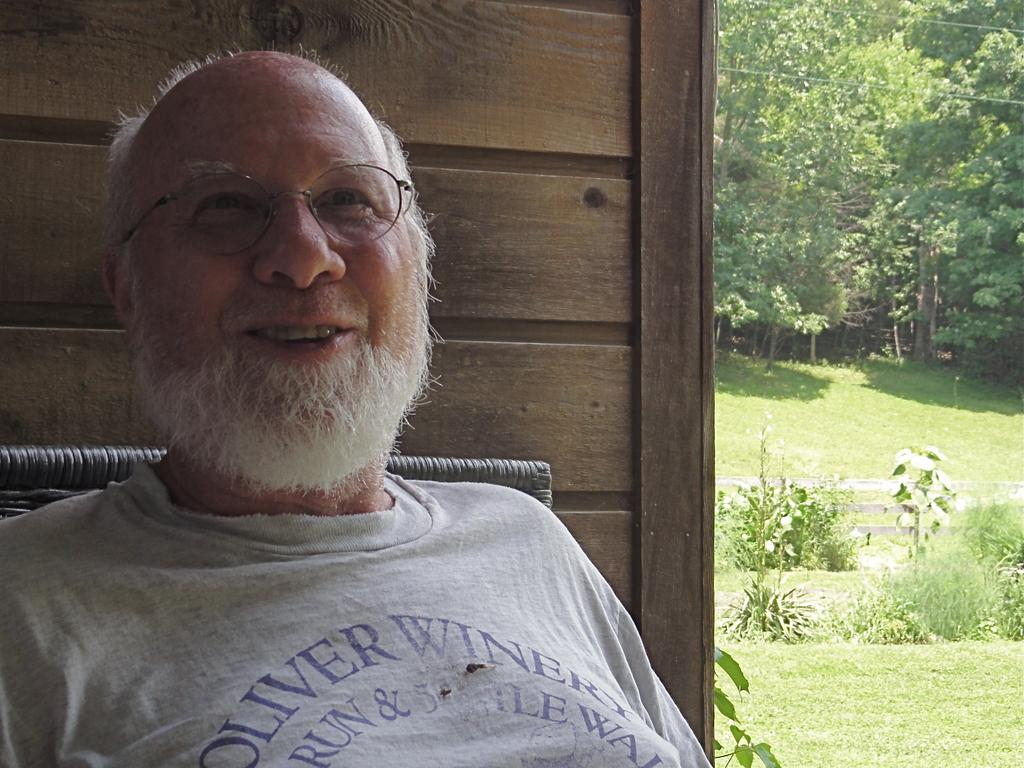What is the main subject of the image? There is a man in the image. Can you describe the man's appearance? The man is wearing spectacles and smiling. What is located behind the man in the image? There is an object behind the man, but its specific details are not mentioned in the facts. What can be seen on the sides or in the background of the image? There is a wall, grass, plants, a fence, and trees visible in the background of the image. How many kittens are playing on the spot in the image? There are no kittens or spots mentioned in the image. What type of gate can be seen in the background of the image? There is no gate present in the image; only a fence is mentioned in the background. 